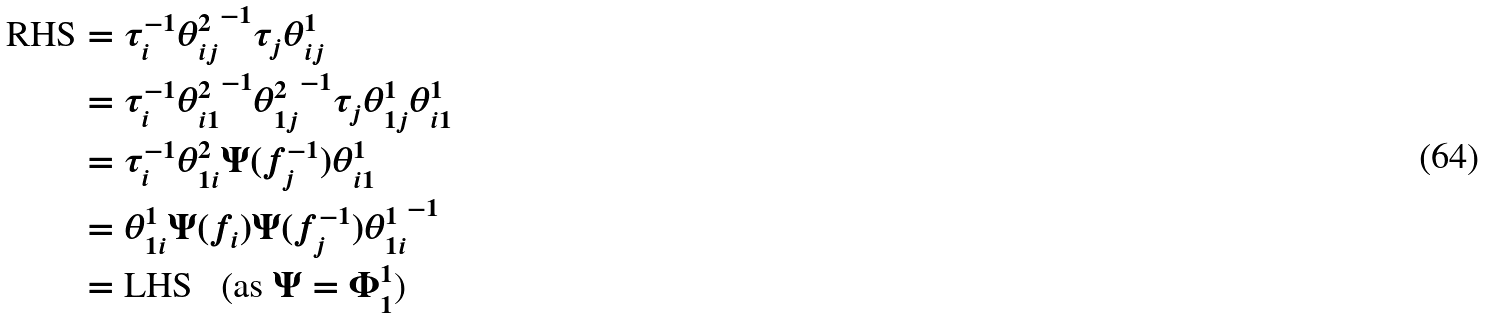Convert formula to latex. <formula><loc_0><loc_0><loc_500><loc_500>\text {RHS} & = \tau _ { i } ^ { - 1 } { \theta ^ { 2 } _ { i j } } ^ { - 1 } \tau _ { j } \theta ^ { 1 } _ { i j } \\ & = \tau _ { i } ^ { - 1 } { \theta ^ { 2 } _ { i 1 } } ^ { - 1 } { \theta ^ { 2 } _ { 1 j } } ^ { - 1 } \tau _ { j } \theta ^ { 1 } _ { 1 j } \theta ^ { 1 } _ { i 1 } \\ & = \tau _ { i } ^ { - 1 } \theta ^ { 2 } _ { 1 i } \Psi ( f _ { j } ^ { - 1 } ) \theta ^ { 1 } _ { i 1 } \\ & = \theta _ { 1 i } ^ { 1 } \Psi ( f _ { i } ) \Psi ( f _ { j } ^ { - 1 } ) { \theta ^ { 1 } _ { 1 i } } ^ { - 1 } \\ & = \text {LHS \ \ (as $\Psi=\Phi^{1}_{1}$)}</formula> 